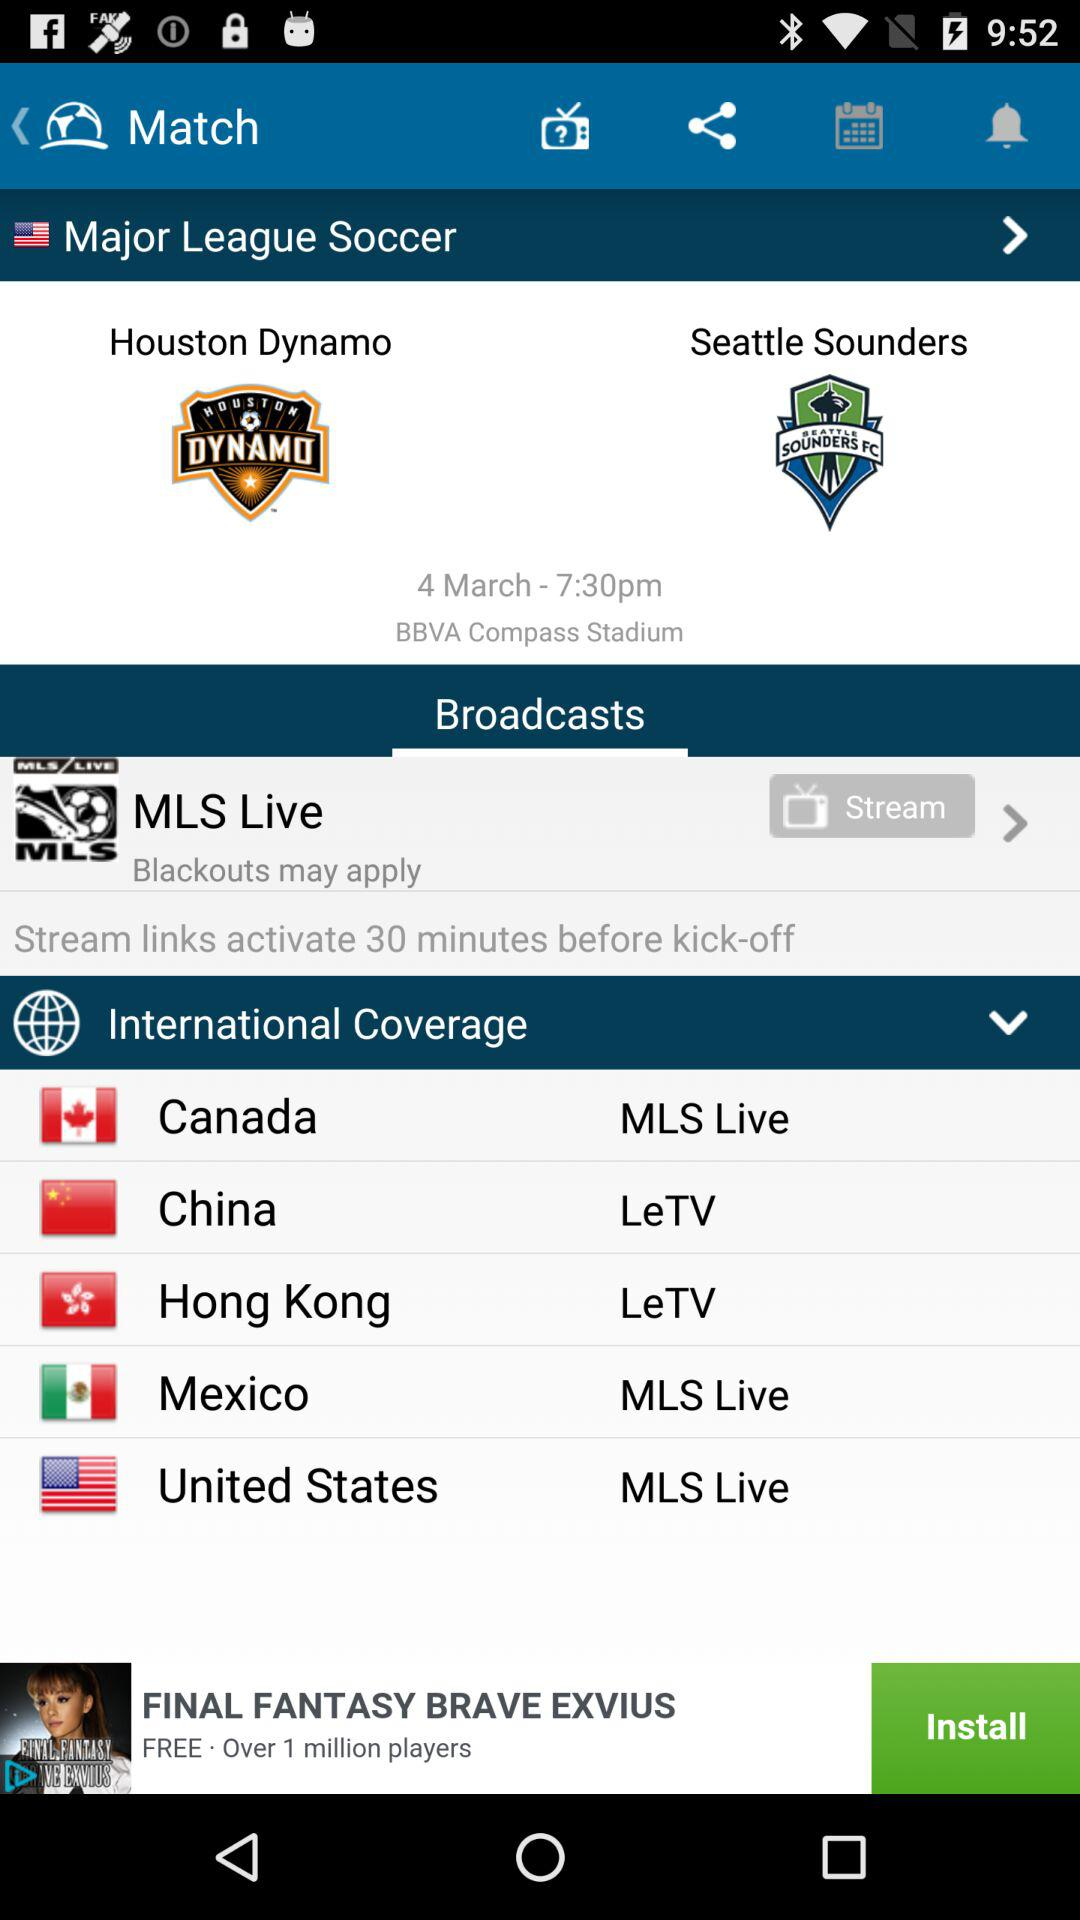In what stadium will the match be played? The match will be played at BBVA Compass Stadium. 